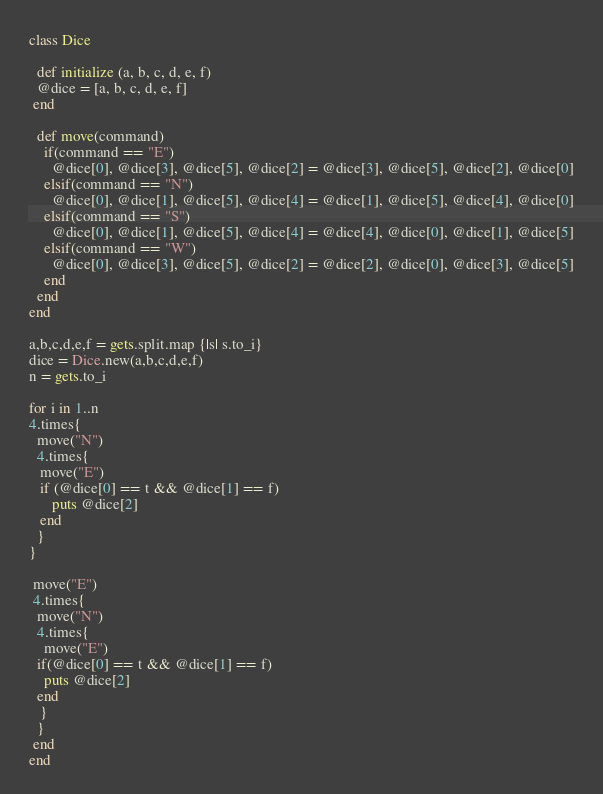Convert code to text. <code><loc_0><loc_0><loc_500><loc_500><_Ruby_>class Dice
  
  def initialize (a, b, c, d, e, f)
  @dice = [a, b, c, d, e, f]
 end 
 
  def move(command)
    if(command == "E") 
      @dice[0], @dice[3], @dice[5], @dice[2] = @dice[3], @dice[5], @dice[2], @dice[0]
    elsif(command == "N") 
      @dice[0], @dice[1], @dice[5], @dice[4] = @dice[1], @dice[5], @dice[4], @dice[0]
    elsif(command == "S") 
      @dice[0], @dice[1], @dice[5], @dice[4] = @dice[4], @dice[0], @dice[1], @dice[5]
    elsif(command == "W") 
      @dice[0], @dice[3], @dice[5], @dice[2] = @dice[2], @dice[0], @dice[3], @dice[5]
    end
  end
end

a,b,c,d,e,f = gets.split.map {|s| s.to_i}
dice = Dice.new(a,b,c,d,e,f)
n = gets.to_i

for i in 1..n
4.times{
  move("N")
  4.times{
   move("E")
   if (@dice[0] == t && @dice[1] == f)
      puts @dice[2]
   end
  }
}

 move("E")
 4.times{
  move("N")
  4.times{
    move("E")
  if(@dice[0] == t && @dice[1] == f)
    puts @dice[2]
  end
   }
  }
 end
end
</code> 